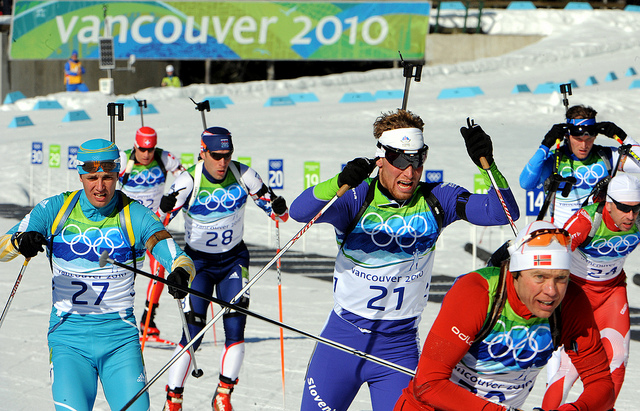Can you describe the atmosphere of this ski race? The atmosphere of this ski race is electric and full of competitive spirit. Athletes are pushing their limits, moving swiftly across the snow with determination etched on their faces. The bright colors of their uniforms and the pristine white snow create a visually striking contrast. Spectators and team members might be cheering on the sidelines, though not visible in this frame. The event is likely accompanied by the sounds of skis slicing through the snow and the occasional clink of ski poles. The backdrop features the 'Vancouver 2010' banners, adding a touch of grandeur and importance to the scene. Overall, the image captures the intense focus and excitement characteristic of a high-stakes sports event. What are some challenges the athletes face during this competition? Athletes in this ski race face several significant challenges. Firstly, maintaining balance and speed on the icy, uneven terrain requires immense skill and physical strength. The cold weather conditions can be grueling, necessitating the athletes to wear appropriate gear to keep warm while not compromising on agility. Visibility might be an issue due to glare from the snow, making the use of goggles essential. Endurance plays a crucial role, as sustaining high energy and focus throughout the race is demanding. Additionally, navigating through the course, marked with flags or indicators, requires strategic maneuvers to avoid potential collisions with other skiers. Lastly, the pressure of representing their countries in an event like the Olympics is a mental challenge, demanding psychological resilience. 